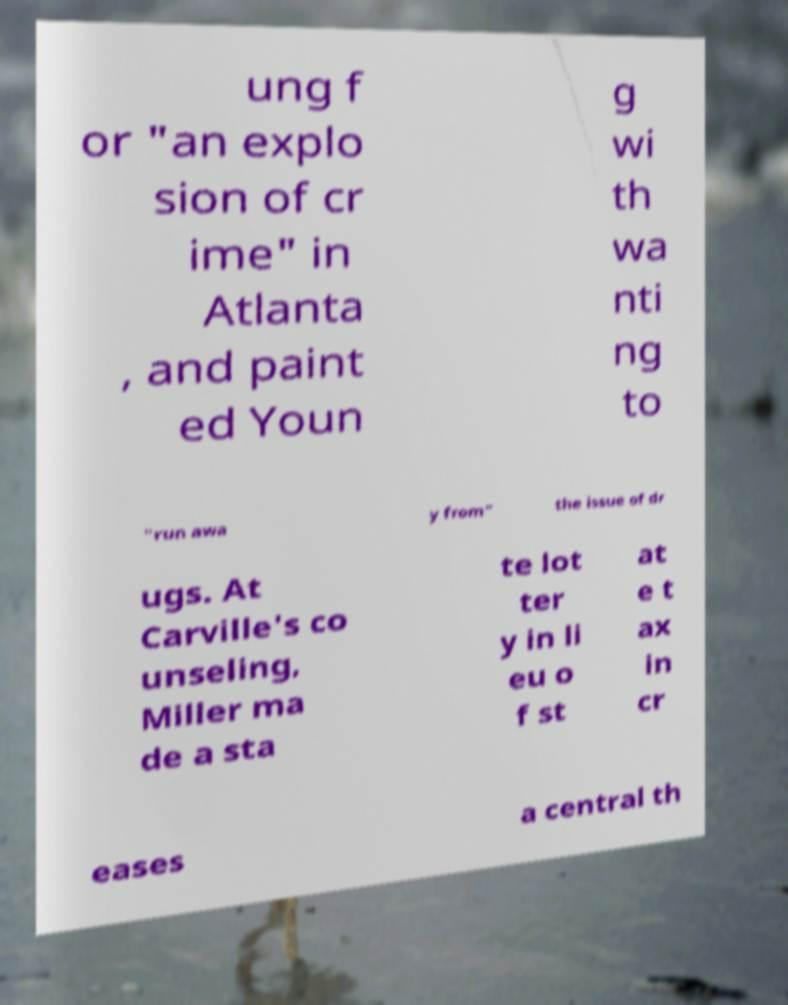Can you read and provide the text displayed in the image?This photo seems to have some interesting text. Can you extract and type it out for me? ung f or "an explo sion of cr ime" in Atlanta , and paint ed Youn g wi th wa nti ng to "run awa y from" the issue of dr ugs. At Carville's co unseling, Miller ma de a sta te lot ter y in li eu o f st at e t ax in cr eases a central th 